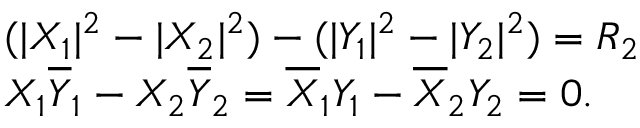Convert formula to latex. <formula><loc_0><loc_0><loc_500><loc_500>\begin{array} { l c r } { { ( | X _ { 1 } | ^ { 2 } - | X _ { 2 } | ^ { 2 } ) - ( | Y _ { 1 } | ^ { 2 } - | Y _ { 2 } | ^ { 2 } ) = R _ { 2 } } } \\ { { X _ { 1 } \overline { Y } _ { 1 } - X _ { 2 } \overline { Y } _ { 2 } = \overline { X } _ { 1 } Y _ { 1 } - \overline { X } _ { 2 } Y _ { 2 } = 0 . } } \end{array}</formula> 